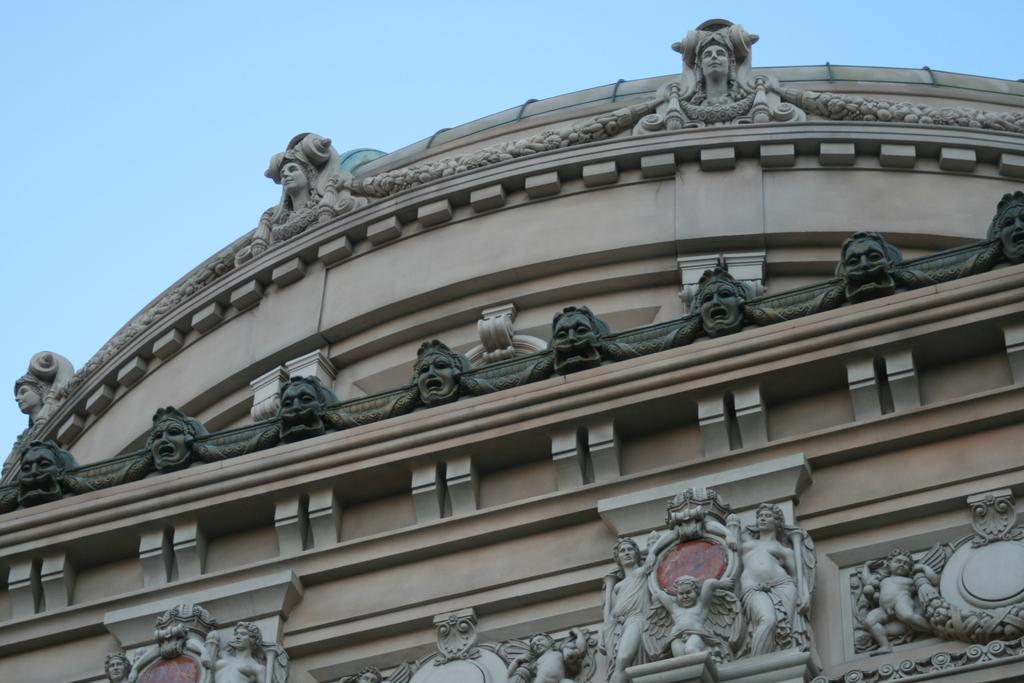What type of artwork can be seen on the wall in the image? There are carved sculptures on the wall in the image. What can be seen in the background of the image? The sky is visible in the image. What type of trousers are hanging on the wall in the image? There are no trousers present in the image; it features carved sculptures on the wall. What mark can be seen on the sky in the image? There is no mark on the sky in the image; the sky is clear and visible. 